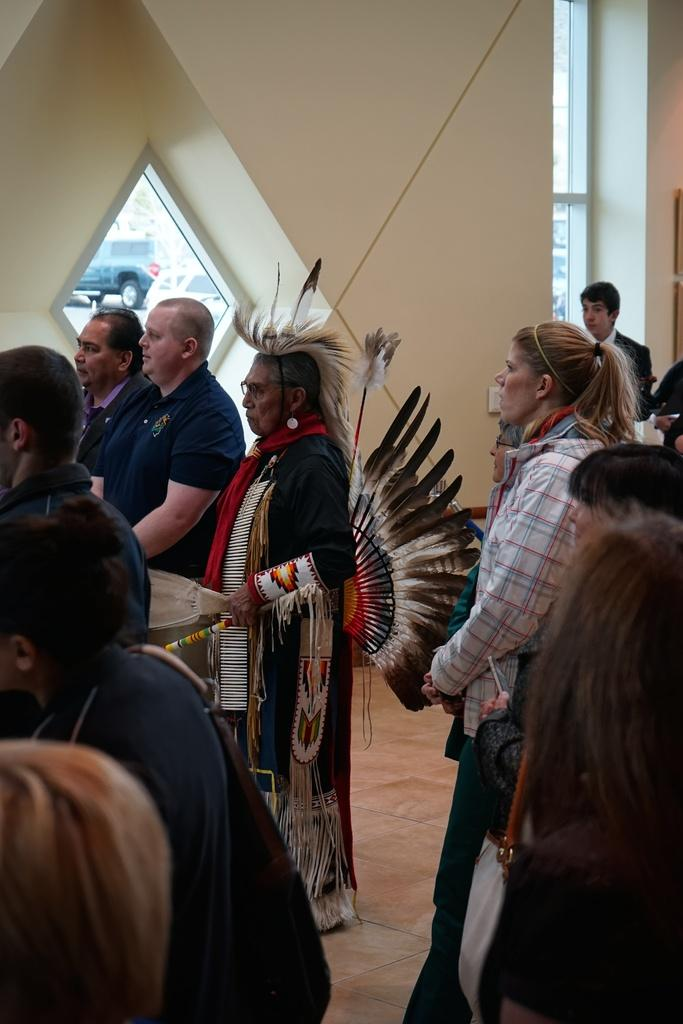What can be observed about the people in the image? There are people standing in the image, including men and women. Can you describe the background of the image? There is a wall in the background of the image. What type of order is being given by the tiger in the image? There is no tiger present in the image, so no order can be given by a tiger. 